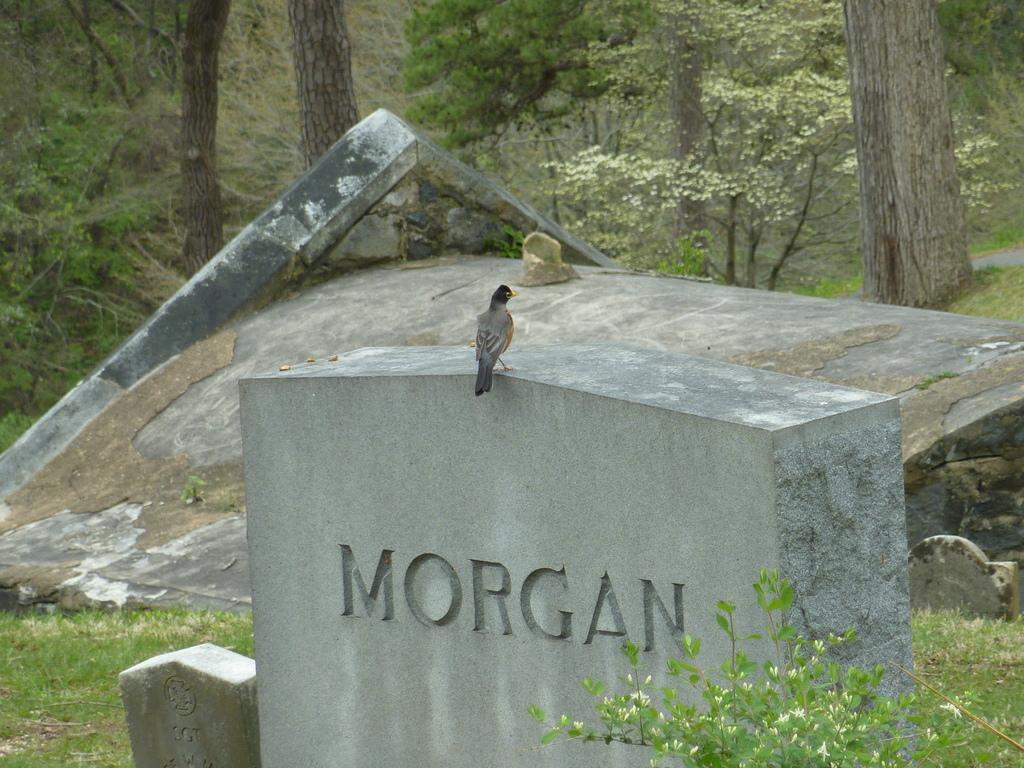What type of animal can be seen in the image? There is a bird in the image. Where is the bird located? The bird is on the surface of a stone wall. What can be seen in the background of the image? There are trees in the background of the image. What type of fang can be seen in the image? There is no fang present in the image; it features a bird on a stone wall with trees in the background. 